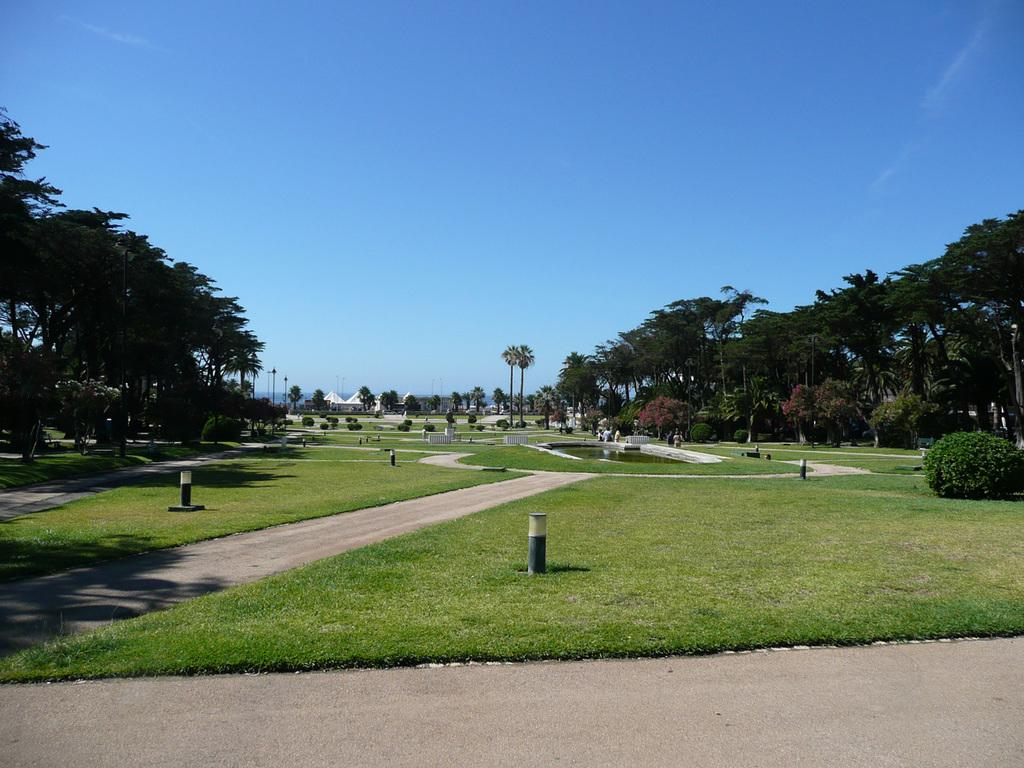What type of vegetation can be seen in the image? There is grass and trees in the image. What structures are present in the image? There are poles and a tent in the image. What is visible in the sky in the image? The sky is visible in the image. What type of surface can be seen in the image? There is a path in the image. What other living organisms can be seen in the image? There are plants in the image. What type of shirt is the creature wearing in the image? There is no creature present in the image, and therefore no shirt can be observed. What is the creature using to take a bath in the image? There is no creature or tub present in the image, so no bathing activity can be observed. 